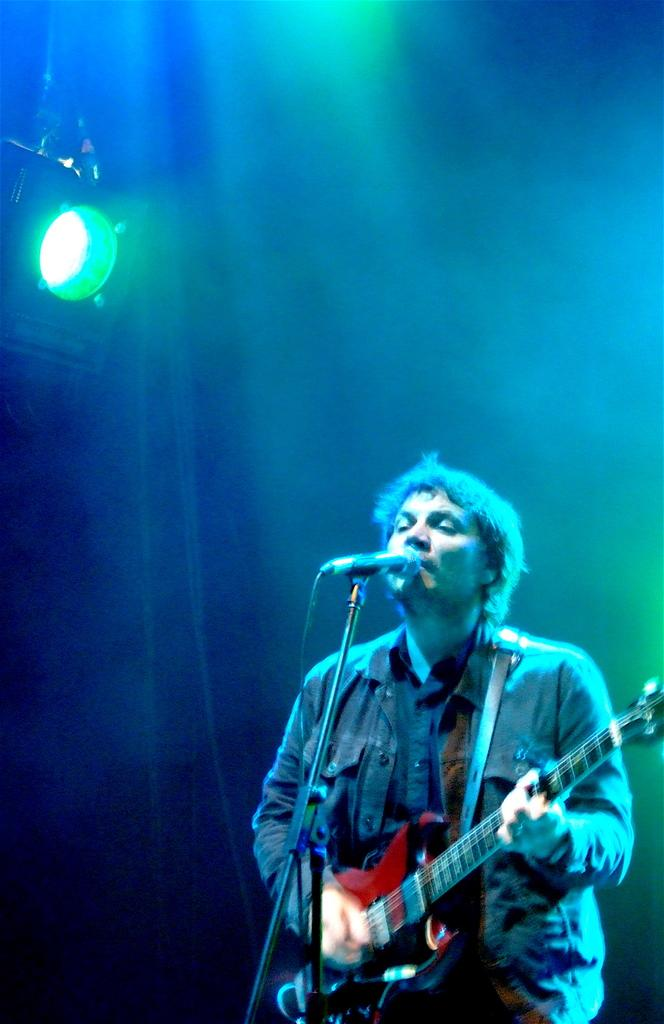What is the man in the image doing? The man is playing a guitar. What is the man standing in front of? The man is standing in front of a mic. What color is the light in the background of the image? There is a green light in the background of the image. Is the man riding a bike in the image? No, the man is not riding a bike in the image; he is playing a guitar and standing in front of a mic. Is there an amusement park visible in the image? No, there is no amusement park visible in the image; only the man, his guitar, the mic, and the green light in the background are present. 